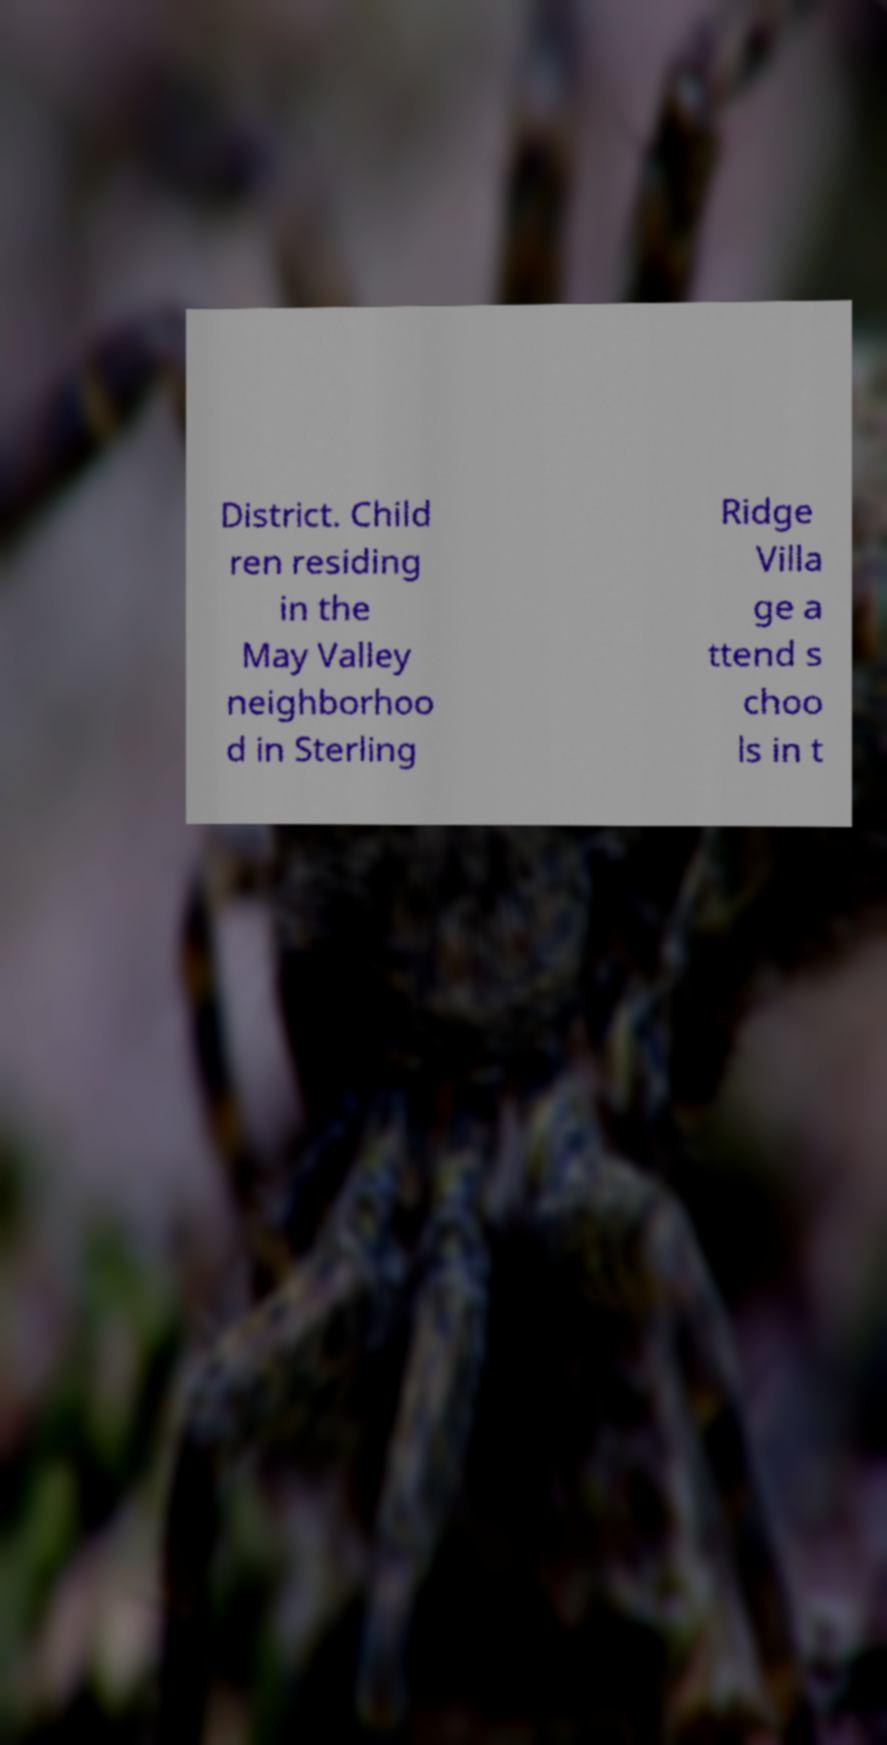Could you extract and type out the text from this image? District. Child ren residing in the May Valley neighborhoo d in Sterling Ridge Villa ge a ttend s choo ls in t 